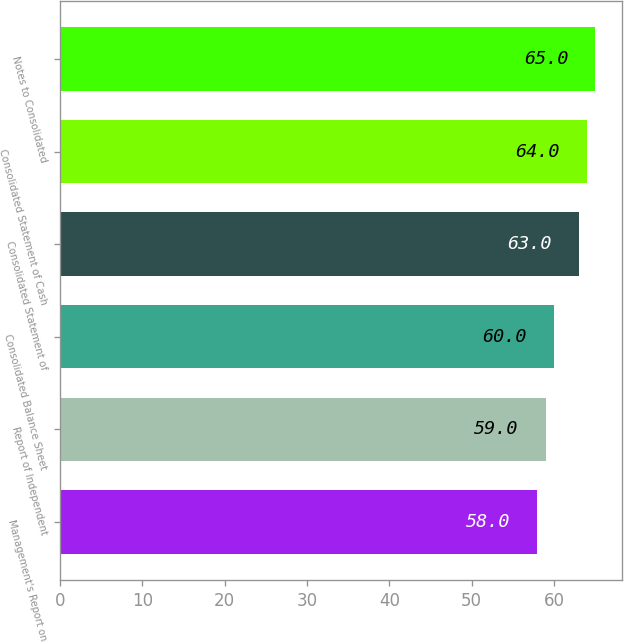Convert chart to OTSL. <chart><loc_0><loc_0><loc_500><loc_500><bar_chart><fcel>Management's Report on<fcel>Report of Independent<fcel>Consolidated Balance Sheet<fcel>Consolidated Statement of<fcel>Consolidated Statement of Cash<fcel>Notes to Consolidated<nl><fcel>58<fcel>59<fcel>60<fcel>63<fcel>64<fcel>65<nl></chart> 